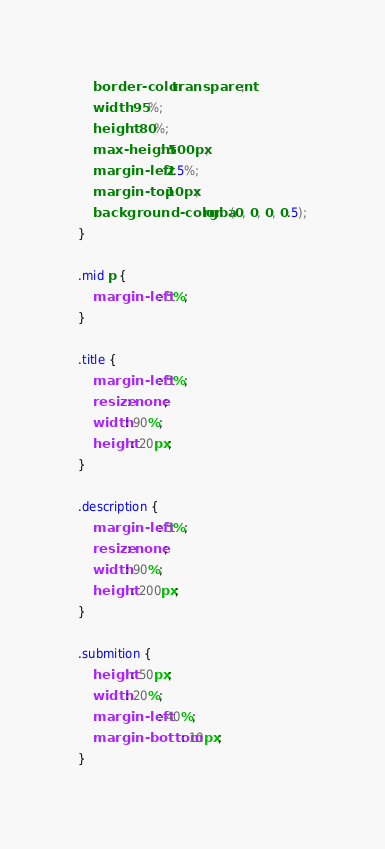Convert code to text. <code><loc_0><loc_0><loc_500><loc_500><_CSS_>    border-color: transparent;
    width: 95%;
    height: 80%;
    max-height: 500px;
    margin-left: 2.5%;
    margin-top: 10px;
    background-color: rgba(0, 0, 0, 0.5);
}

.mid p {
    margin-left: 5%;
}

.title {
    margin-left: 5%;
    resize: none;
    width: 90%;
    height: 20px;
}

.description {
    margin-left: 5%;
    resize: none;
    width: 90%;
    height: 200px;
}

.submition {
    height: 50px;
    width: 20%;
    margin-left: 40%;
    margin-bottom: 10px;
}</code> 